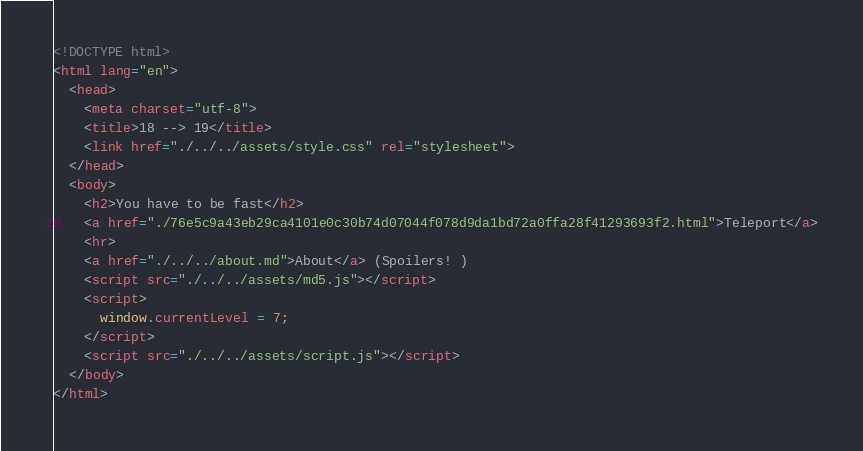Convert code to text. <code><loc_0><loc_0><loc_500><loc_500><_HTML_><!DOCTYPE html>
<html lang="en">
  <head>
    <meta charset="utf-8">
    <title>18 --> 19</title>
    <link href="./../../assets/style.css" rel="stylesheet">
  </head>
  <body>
    <h2>You have to be fast</h2>
    <a href="./76e5c9a43eb29ca4101e0c30b74d07044f078d9da1bd72a0ffa28f41293693f2.html">Teleport</a>
    <hr>
    <a href="./../../about.md">About</a> (Spoilers! )
    <script src="./../../assets/md5.js"></script>
    <script>
      window.currentLevel = 7;
    </script>
    <script src="./../../assets/script.js"></script>
  </body>
</html></code> 